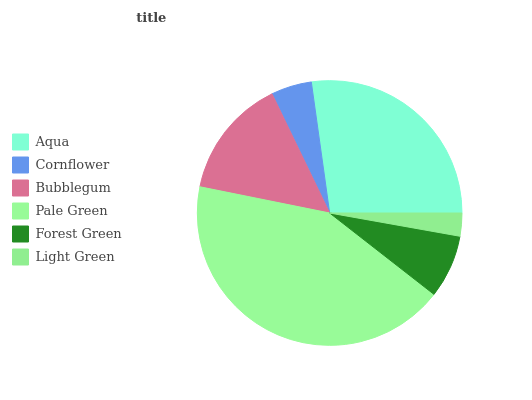Is Light Green the minimum?
Answer yes or no. Yes. Is Pale Green the maximum?
Answer yes or no. Yes. Is Cornflower the minimum?
Answer yes or no. No. Is Cornflower the maximum?
Answer yes or no. No. Is Aqua greater than Cornflower?
Answer yes or no. Yes. Is Cornflower less than Aqua?
Answer yes or no. Yes. Is Cornflower greater than Aqua?
Answer yes or no. No. Is Aqua less than Cornflower?
Answer yes or no. No. Is Bubblegum the high median?
Answer yes or no. Yes. Is Forest Green the low median?
Answer yes or no. Yes. Is Pale Green the high median?
Answer yes or no. No. Is Cornflower the low median?
Answer yes or no. No. 